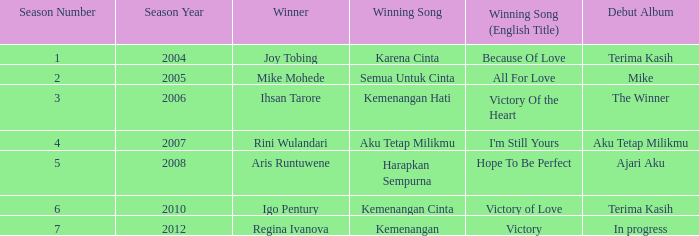Which English winning song had the winner aris runtuwene? Hope To Be Perfect. 